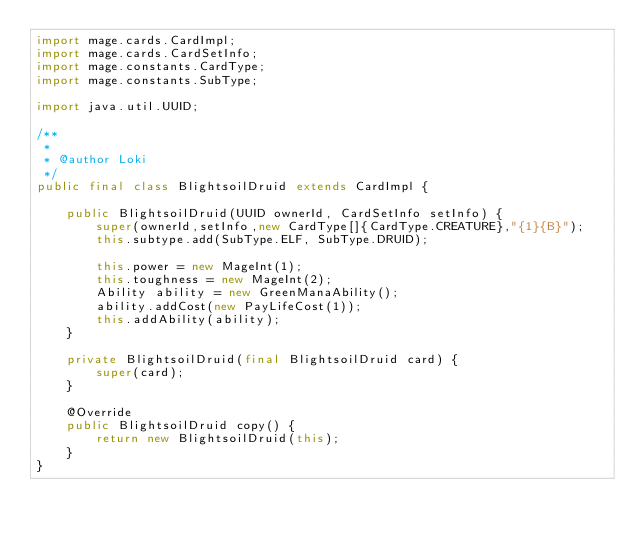<code> <loc_0><loc_0><loc_500><loc_500><_Java_>import mage.cards.CardImpl;
import mage.cards.CardSetInfo;
import mage.constants.CardType;
import mage.constants.SubType;

import java.util.UUID;

/**
 *
 * @author Loki
 */
public final class BlightsoilDruid extends CardImpl {

    public BlightsoilDruid(UUID ownerId, CardSetInfo setInfo) {
        super(ownerId,setInfo,new CardType[]{CardType.CREATURE},"{1}{B}");
        this.subtype.add(SubType.ELF, SubType.DRUID);

        this.power = new MageInt(1);
        this.toughness = new MageInt(2);
        Ability ability = new GreenManaAbility();
        ability.addCost(new PayLifeCost(1));
        this.addAbility(ability);
    }

    private BlightsoilDruid(final BlightsoilDruid card) {
        super(card);
    }

    @Override
    public BlightsoilDruid copy() {
        return new BlightsoilDruid(this);
    }
}
</code> 